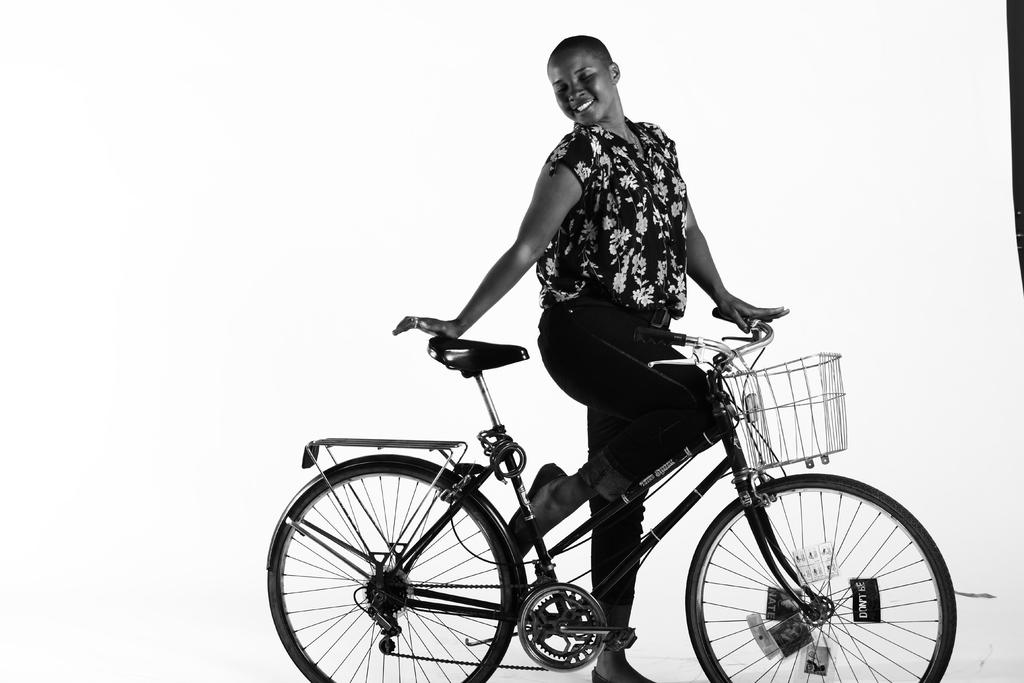What is the main subject of the image? There is a person in the image. What is the person doing in the image? The person is standing and holding a bicycle. What can be observed about the color of the image? The image is in black and white color. Is the person folding a crate in the image? There is no crate present in the image, and the person is not folding anything. 